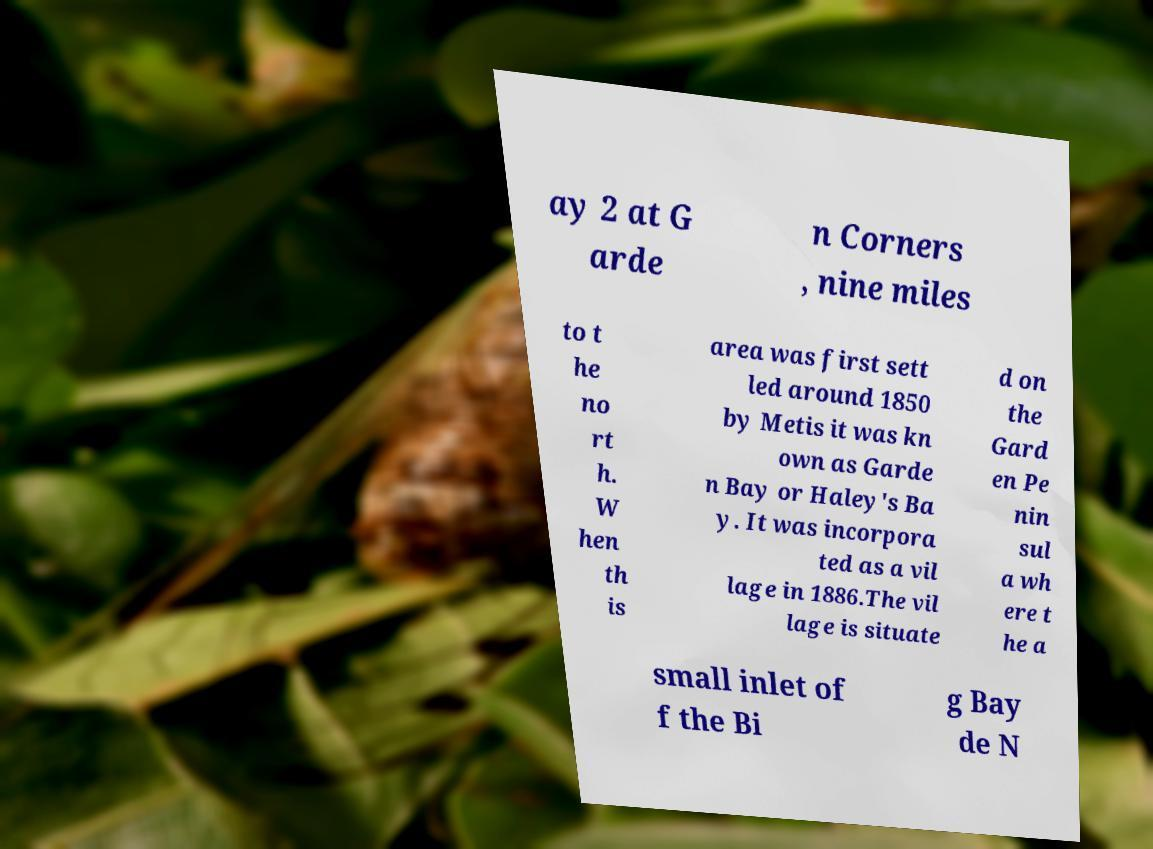Please read and relay the text visible in this image. What does it say? ay 2 at G arde n Corners , nine miles to t he no rt h. W hen th is area was first sett led around 1850 by Metis it was kn own as Garde n Bay or Haley's Ba y. It was incorpora ted as a vil lage in 1886.The vil lage is situate d on the Gard en Pe nin sul a wh ere t he a small inlet of f the Bi g Bay de N 